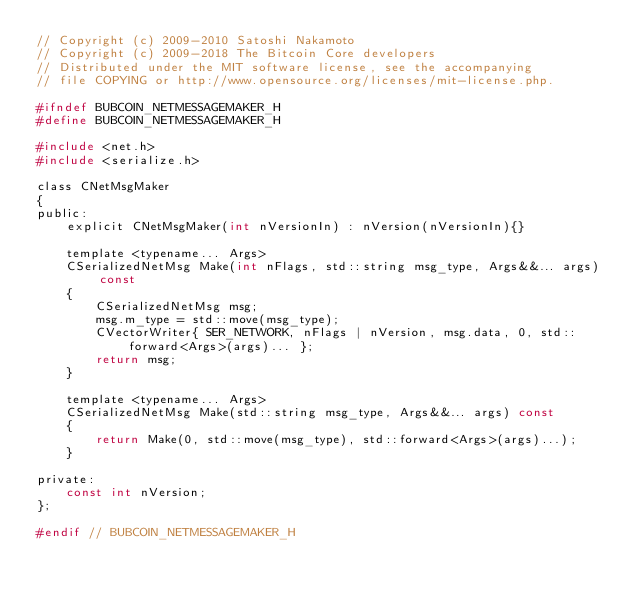<code> <loc_0><loc_0><loc_500><loc_500><_C_>// Copyright (c) 2009-2010 Satoshi Nakamoto
// Copyright (c) 2009-2018 The Bitcoin Core developers
// Distributed under the MIT software license, see the accompanying
// file COPYING or http://www.opensource.org/licenses/mit-license.php.

#ifndef BUBCOIN_NETMESSAGEMAKER_H
#define BUBCOIN_NETMESSAGEMAKER_H

#include <net.h>
#include <serialize.h>

class CNetMsgMaker
{
public:
    explicit CNetMsgMaker(int nVersionIn) : nVersion(nVersionIn){}

    template <typename... Args>
    CSerializedNetMsg Make(int nFlags, std::string msg_type, Args&&... args) const
    {
        CSerializedNetMsg msg;
        msg.m_type = std::move(msg_type);
        CVectorWriter{ SER_NETWORK, nFlags | nVersion, msg.data, 0, std::forward<Args>(args)... };
        return msg;
    }

    template <typename... Args>
    CSerializedNetMsg Make(std::string msg_type, Args&&... args) const
    {
        return Make(0, std::move(msg_type), std::forward<Args>(args)...);
    }

private:
    const int nVersion;
};

#endif // BUBCOIN_NETMESSAGEMAKER_H
</code> 